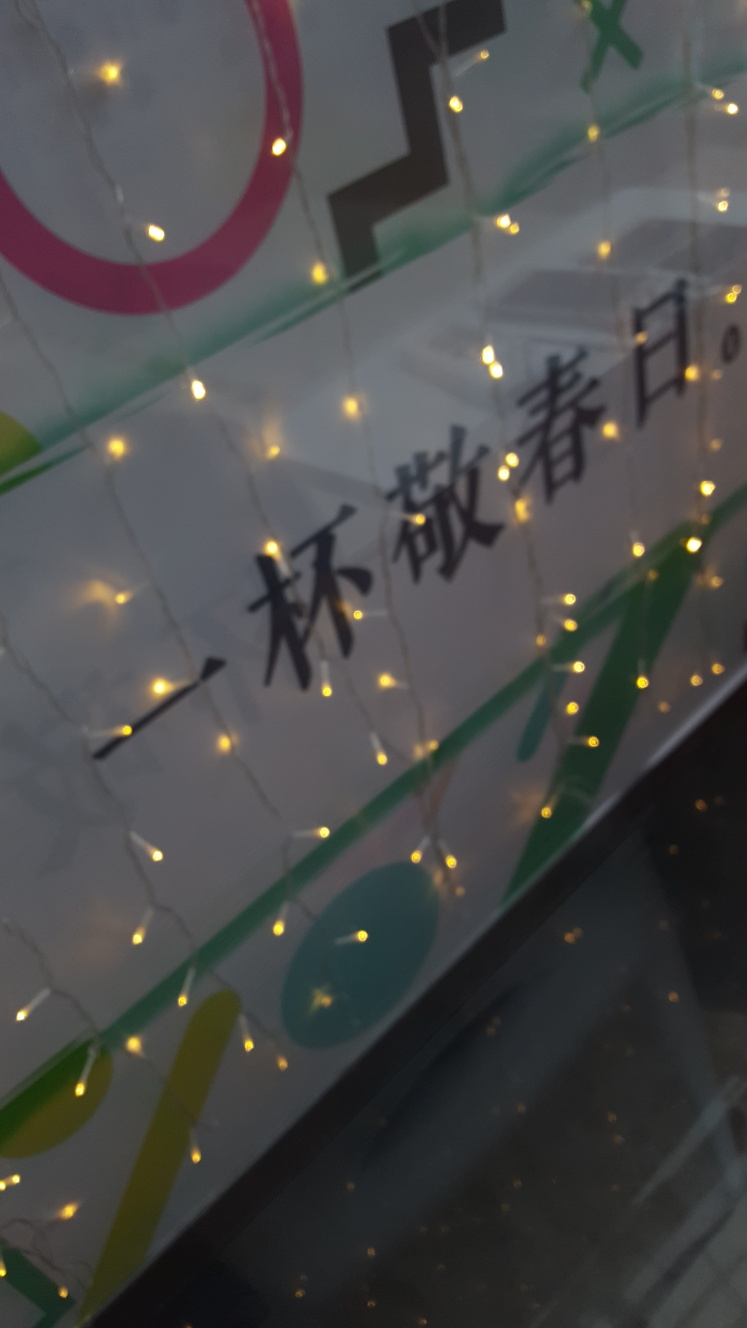Is the outline of the small light bulb blurry?
A. Yes
B. No
Answer with the option's letter from the given choices directly.
 A. 